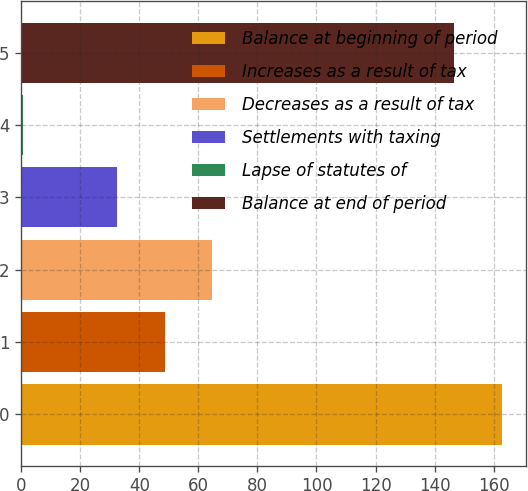Convert chart to OTSL. <chart><loc_0><loc_0><loc_500><loc_500><bar_chart><fcel>Balance at beginning of period<fcel>Increases as a result of tax<fcel>Decreases as a result of tax<fcel>Settlements with taxing<fcel>Lapse of statutes of<fcel>Balance at end of period<nl><fcel>162.69<fcel>48.57<fcel>64.56<fcel>32.58<fcel>0.6<fcel>146.7<nl></chart> 